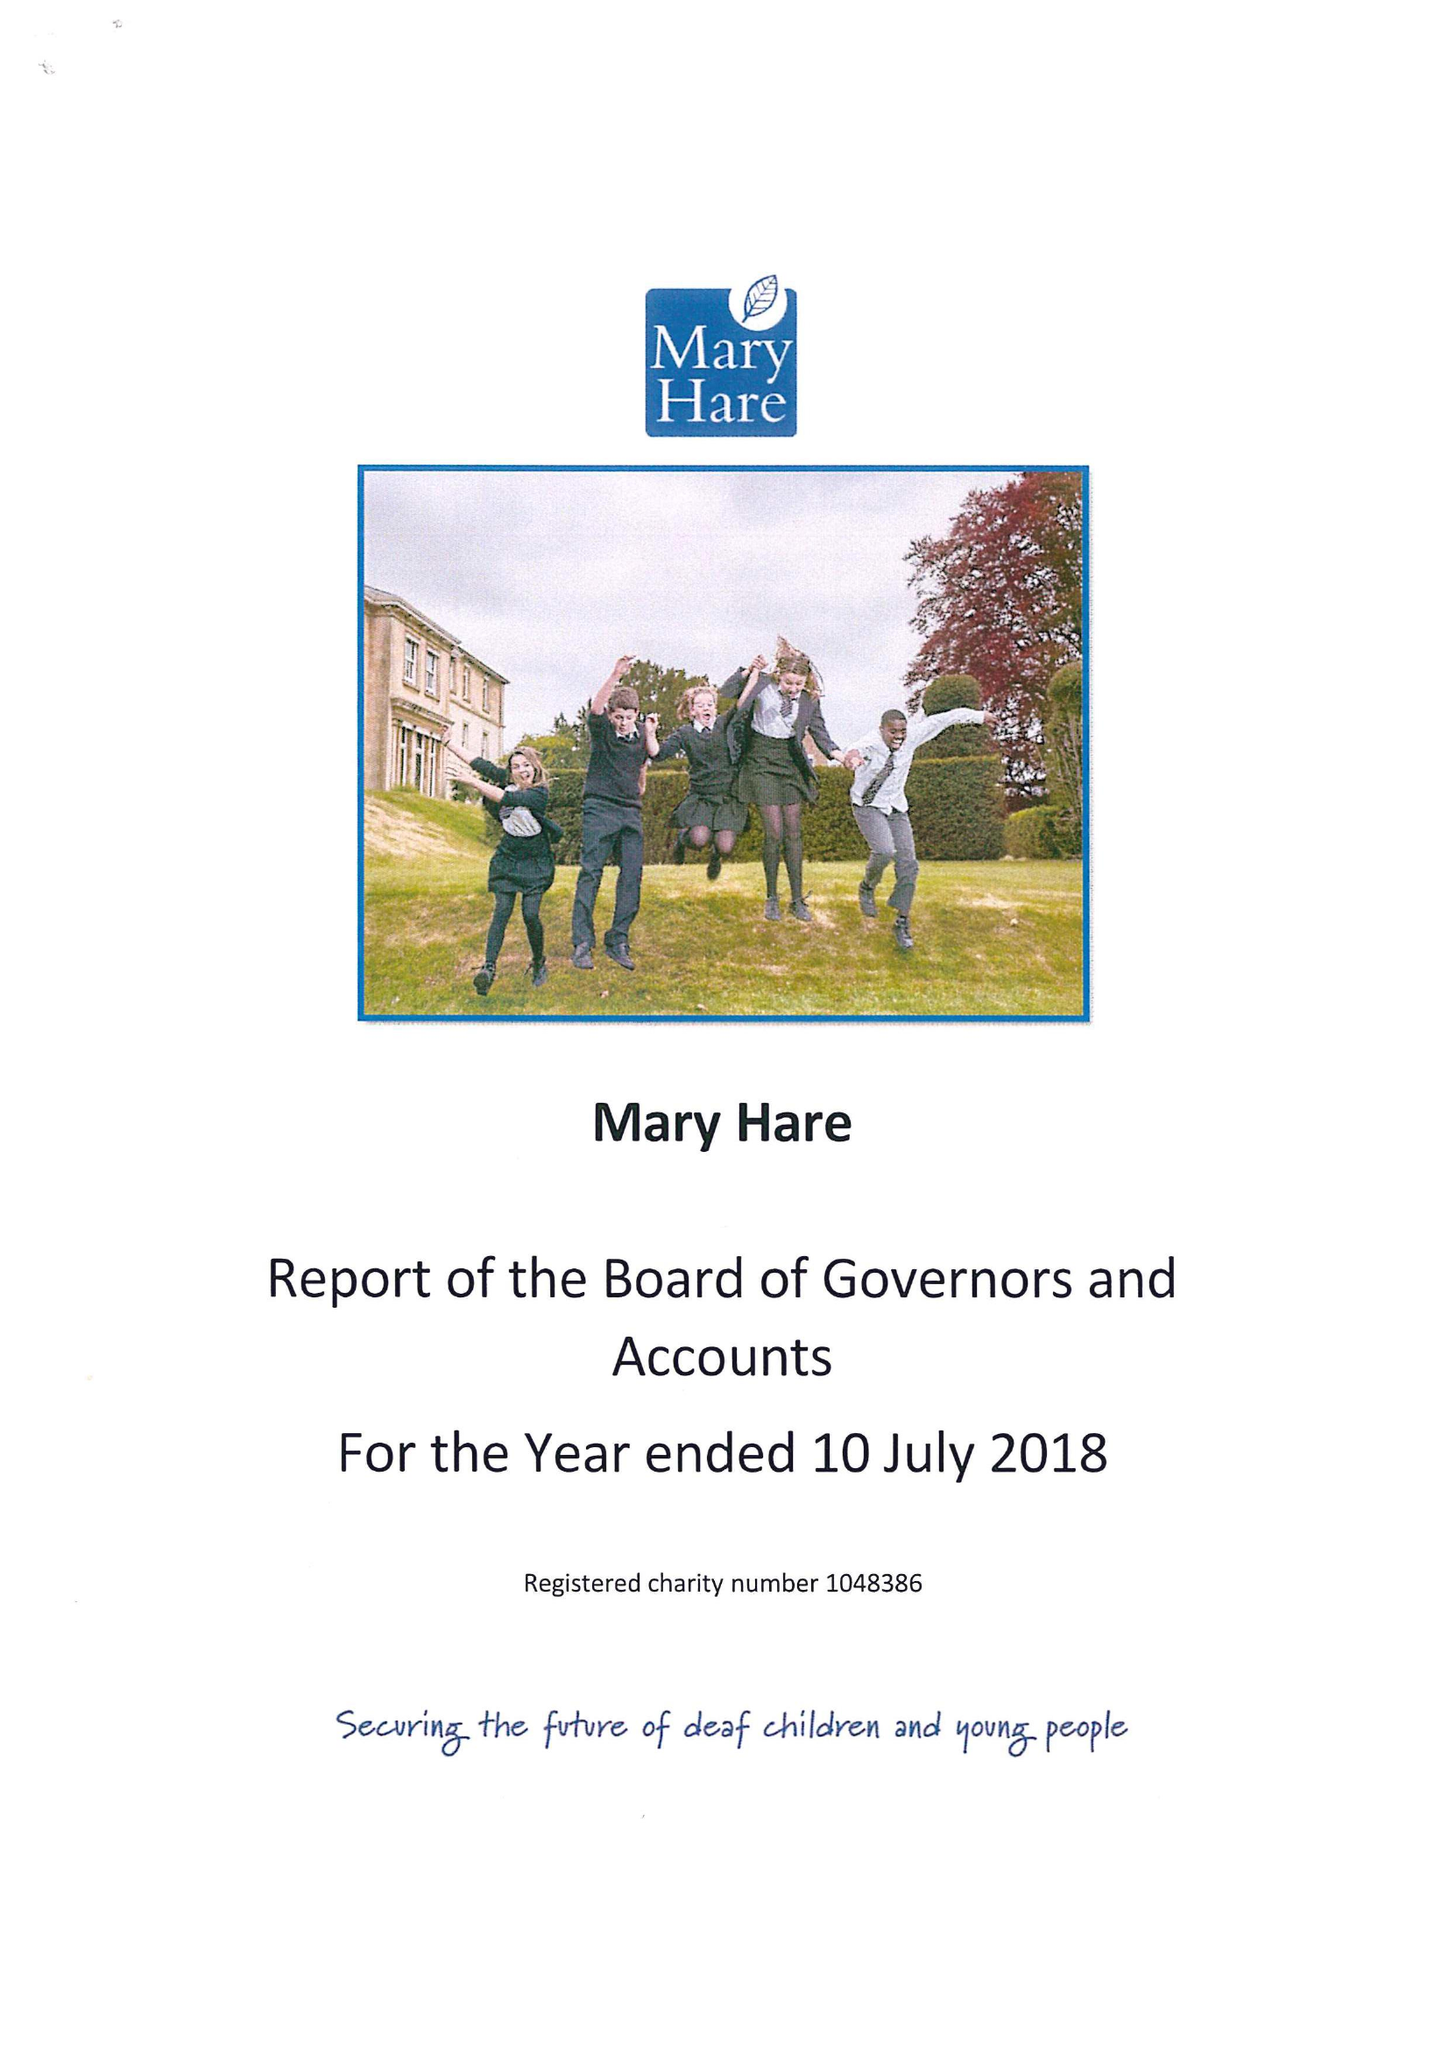What is the value for the report_date?
Answer the question using a single word or phrase. 2018-07-10 